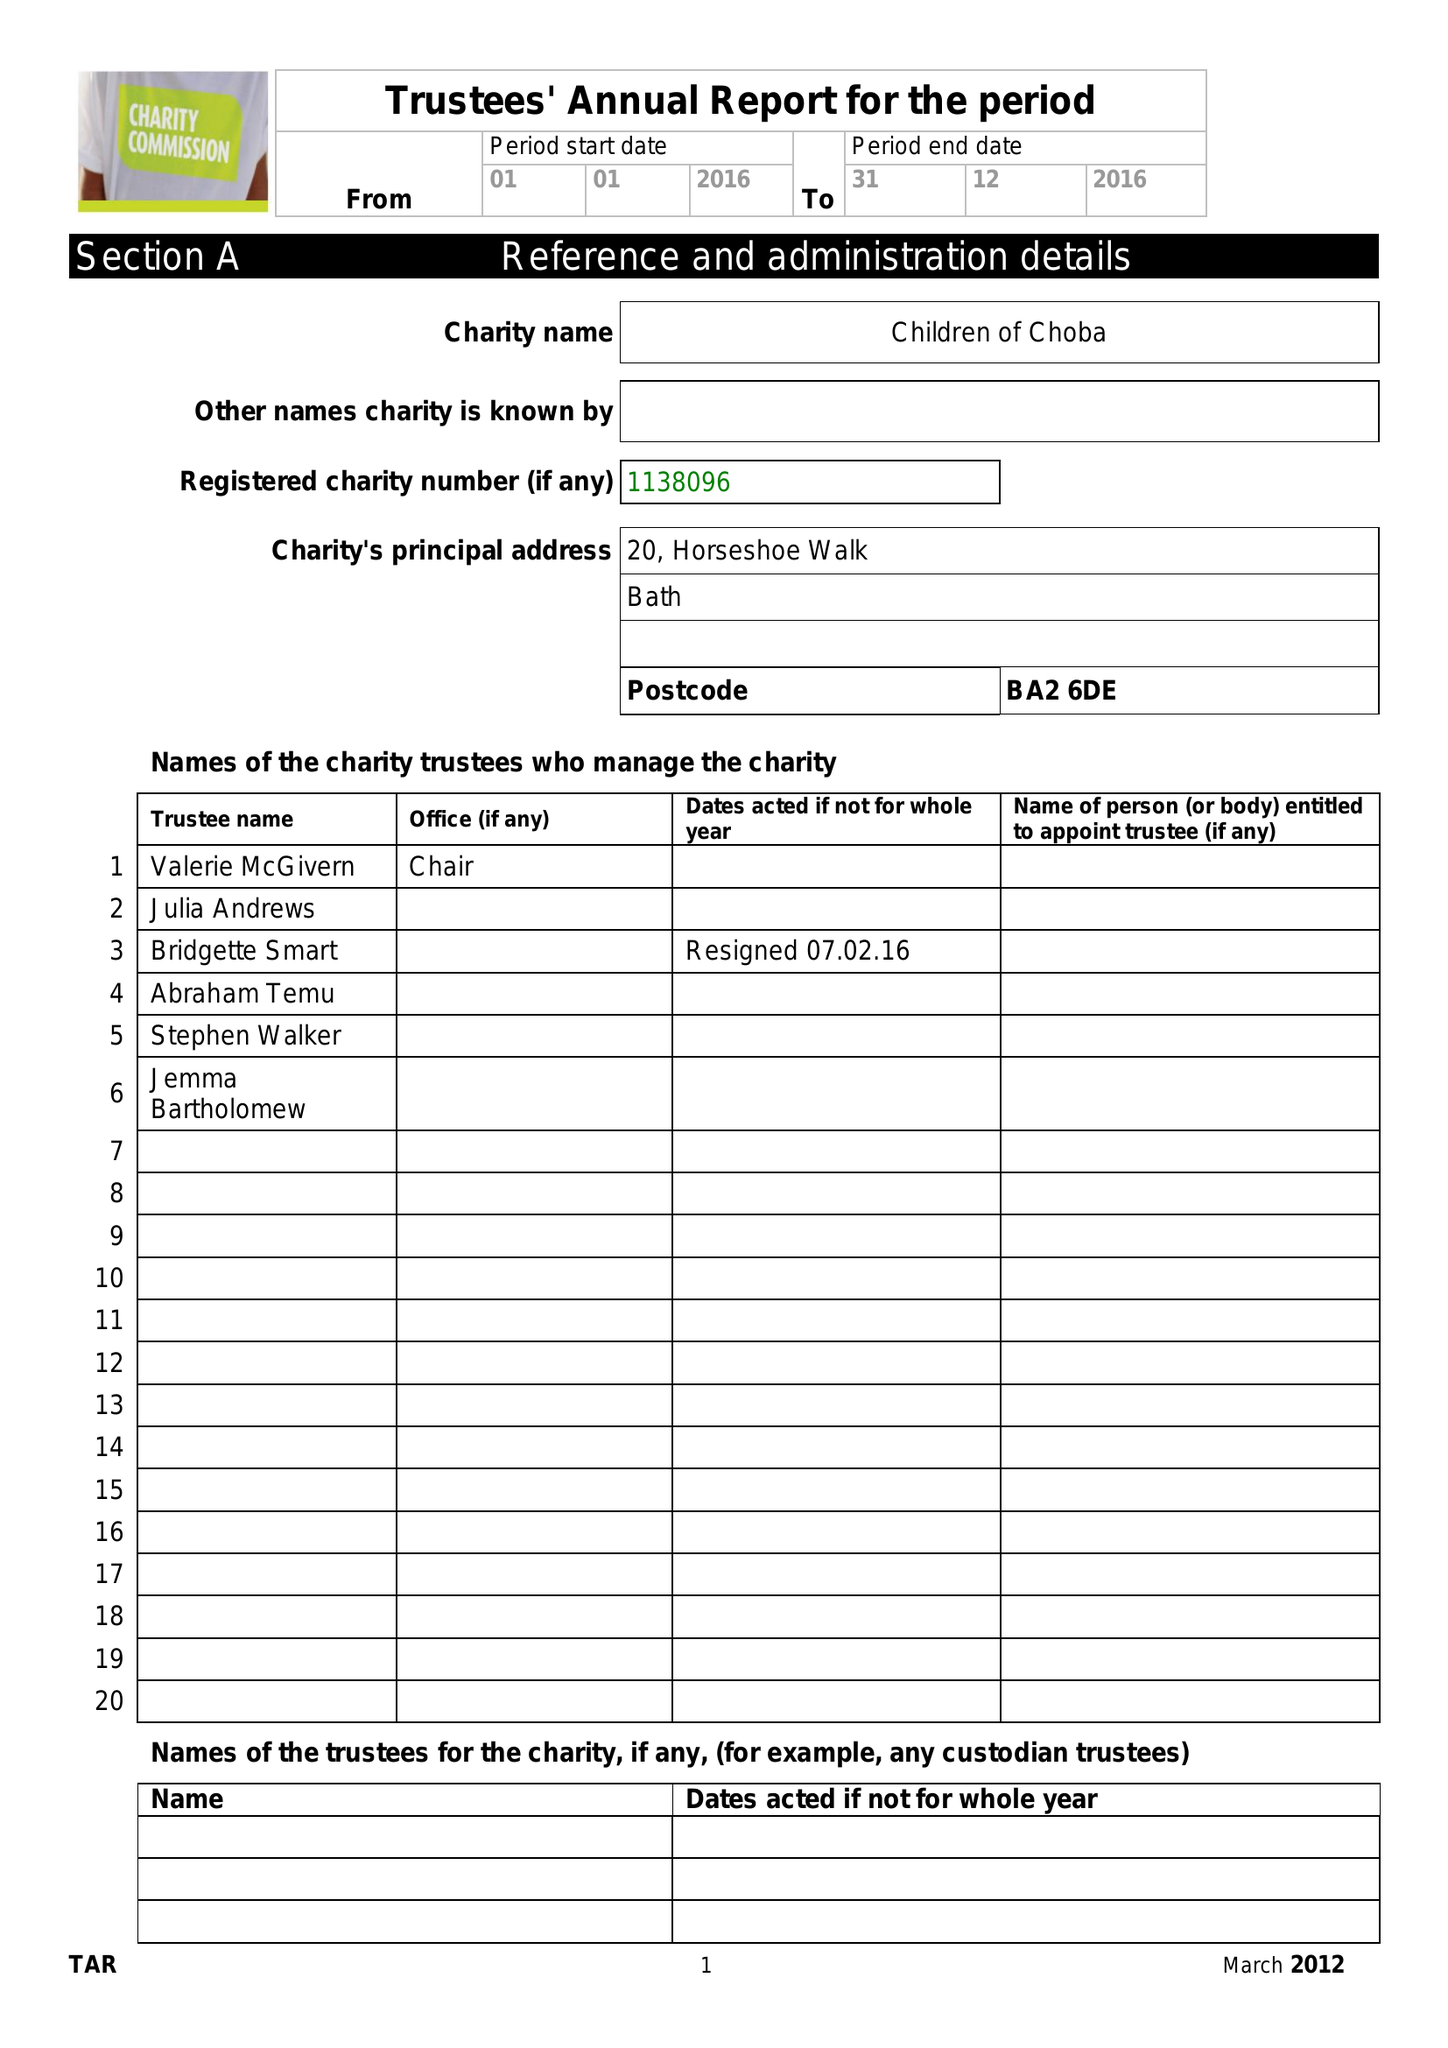What is the value for the income_annually_in_british_pounds?
Answer the question using a single word or phrase. 57000.00 